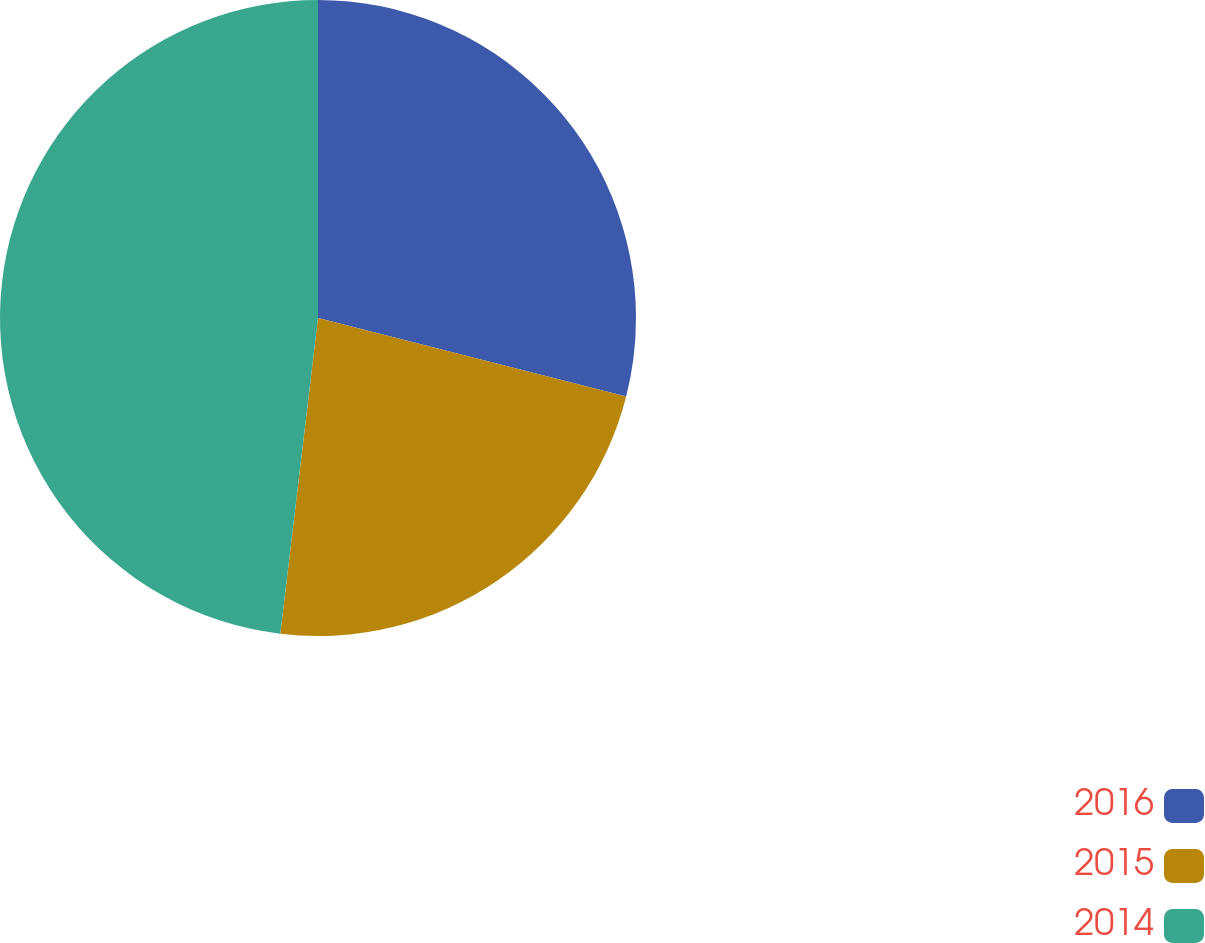Convert chart to OTSL. <chart><loc_0><loc_0><loc_500><loc_500><pie_chart><fcel>2016<fcel>2015<fcel>2014<nl><fcel>28.97%<fcel>22.92%<fcel>48.11%<nl></chart> 